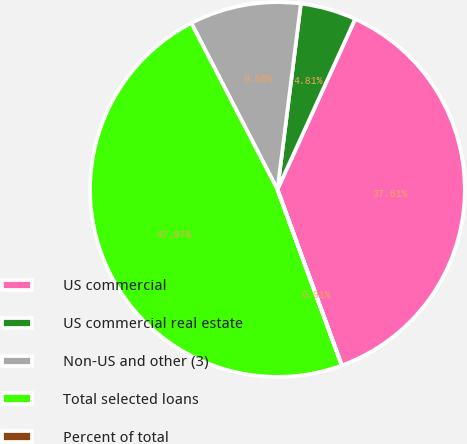Convert chart. <chart><loc_0><loc_0><loc_500><loc_500><pie_chart><fcel>US commercial<fcel>US commercial real estate<fcel>Non-US and other (3)<fcel>Total selected loans<fcel>Percent of total<nl><fcel>37.61%<fcel>4.81%<fcel>9.6%<fcel>47.97%<fcel>0.01%<nl></chart> 